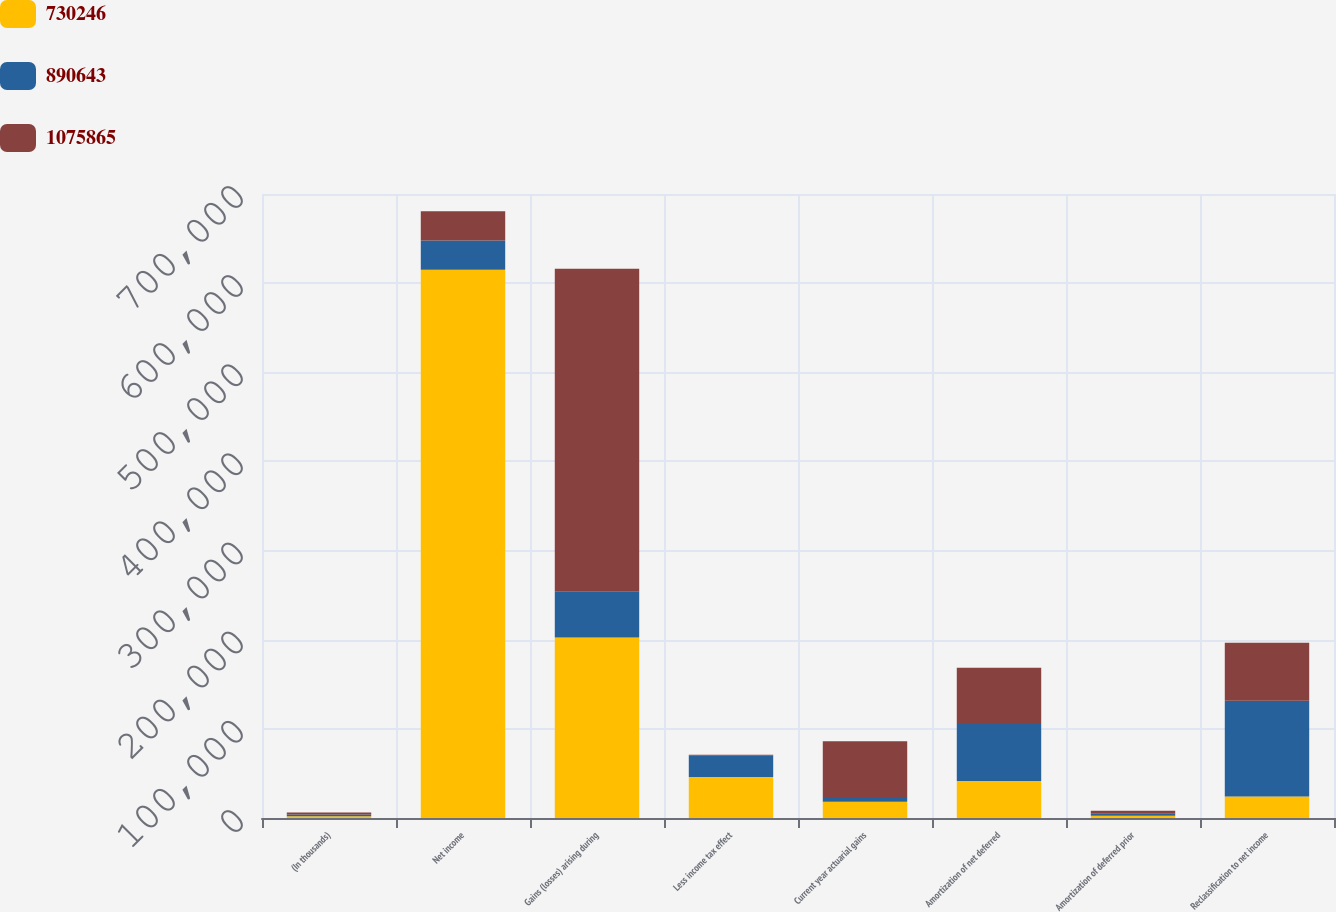Convert chart. <chart><loc_0><loc_0><loc_500><loc_500><stacked_bar_chart><ecel><fcel>(In thousands)<fcel>Net income<fcel>Gains (losses) arising during<fcel>Less income tax effect<fcel>Current year actuarial gains<fcel>Amortization of net deferred<fcel>Amortization of deferred prior<fcel>Reclassification to net income<nl><fcel>730246<fcel>2017<fcel>614923<fcel>202428<fcel>45950<fcel>18130<fcel>41440<fcel>2646<fcel>24067<nl><fcel>890643<fcel>2016<fcel>32911<fcel>52028<fcel>24382<fcel>5384<fcel>65212<fcel>2584<fcel>107457<nl><fcel>1.07586e+06<fcel>2015<fcel>32911<fcel>361814<fcel>586<fcel>62556<fcel>61966<fcel>3038<fcel>64976<nl></chart> 